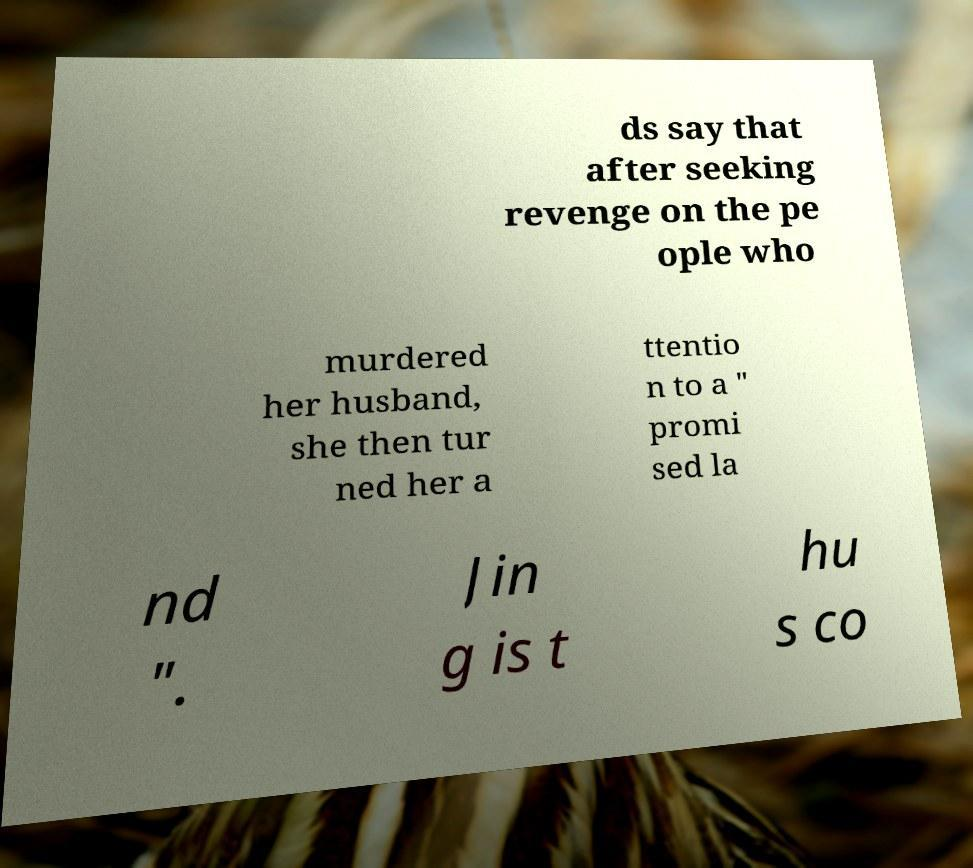Please identify and transcribe the text found in this image. ds say that after seeking revenge on the pe ople who murdered her husband, she then tur ned her a ttentio n to a " promi sed la nd ". Jin g is t hu s co 